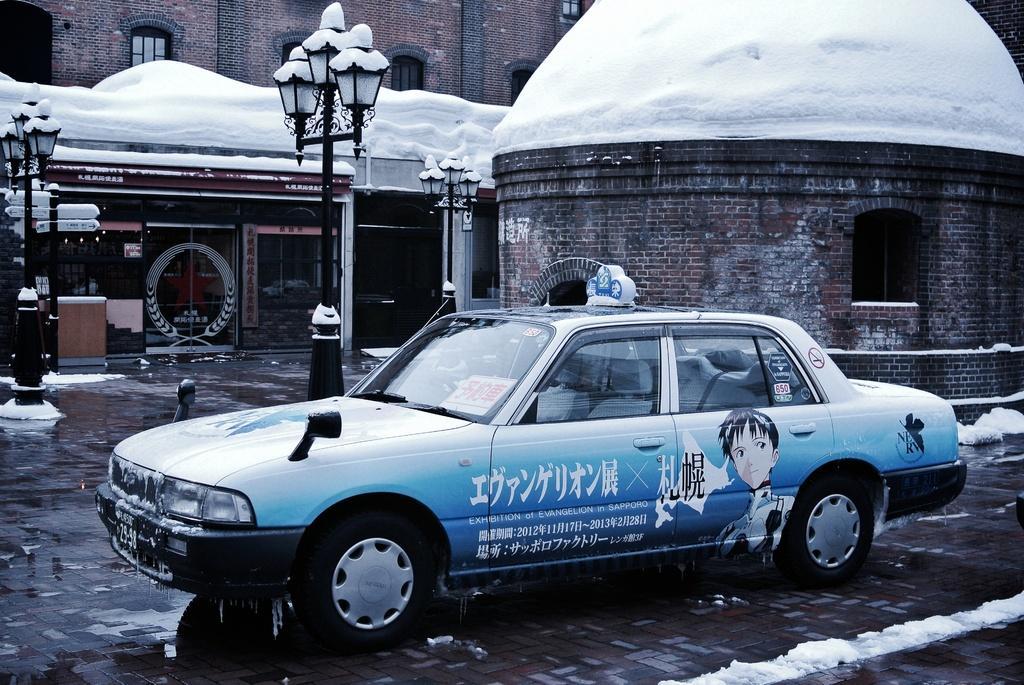Could you give a brief overview of what you see in this image? In this image I can see the ground, some water on the ground, a car which is blue in color, few black colored poles and few buildings. I can see some snow on car, poles and buildings. 